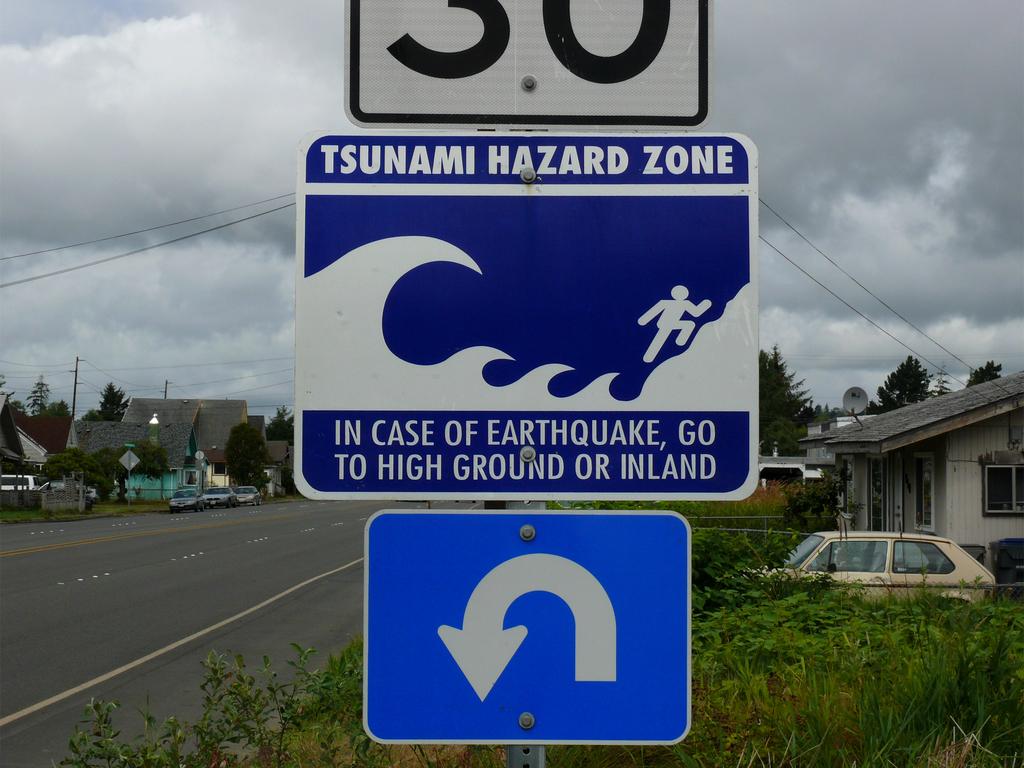What is the warning on the sign?
Your answer should be very brief. Tsunami hazard zone. Tsunami are caused by?
Your response must be concise. Answering does not require reading text in the image. 